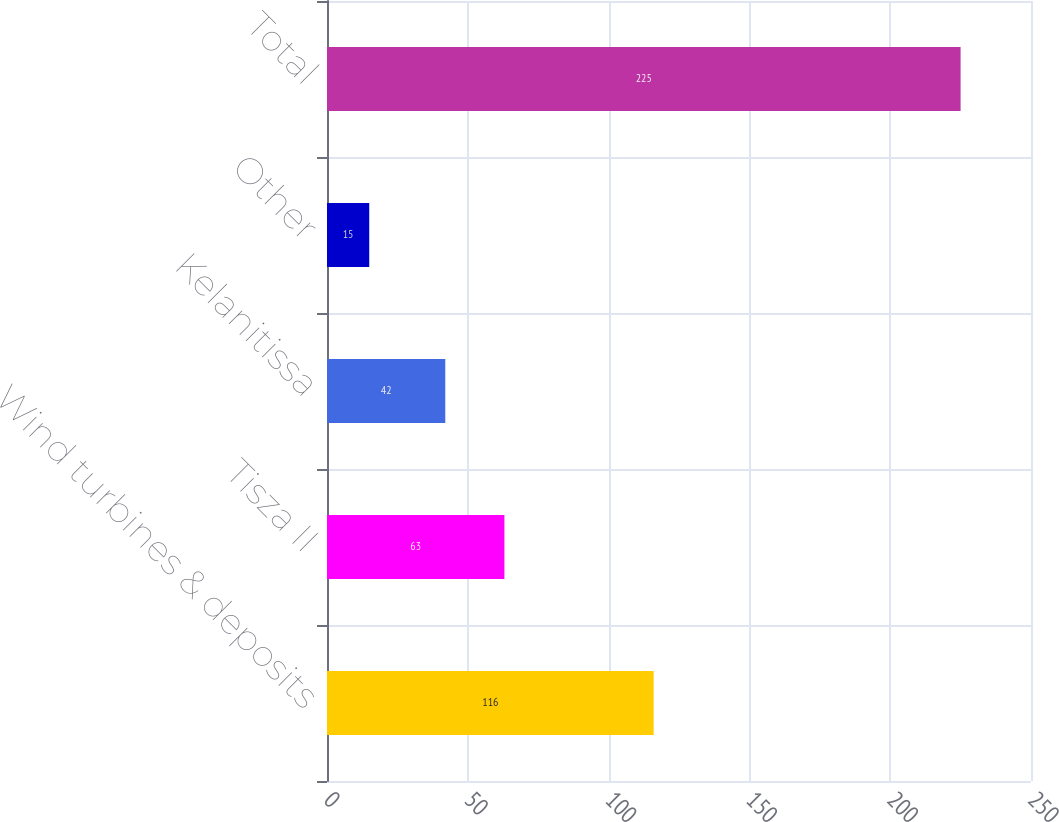<chart> <loc_0><loc_0><loc_500><loc_500><bar_chart><fcel>Wind turbines & deposits<fcel>Tisza II<fcel>Kelanitissa<fcel>Other<fcel>Total<nl><fcel>116<fcel>63<fcel>42<fcel>15<fcel>225<nl></chart> 